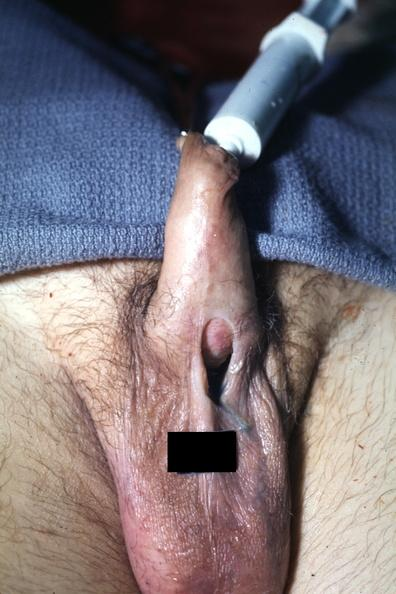s penis present?
Answer the question using a single word or phrase. Yes 